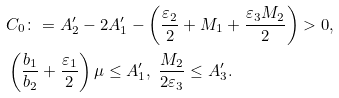<formula> <loc_0><loc_0><loc_500><loc_500>& C _ { 0 } \colon = A ^ { \prime } _ { 2 } - 2 A ^ { \prime } _ { 1 } - \left ( \frac { \varepsilon _ { 2 } } { 2 } + M _ { 1 } + \frac { \varepsilon _ { 3 } M _ { 2 } } { 2 } \right ) > 0 , \\ & \left ( \frac { b _ { 1 } } { b _ { 2 } } + \frac { \varepsilon _ { 1 } } { 2 } \right ) \mu \leq A ^ { \prime } _ { 1 } , \ \frac { M _ { 2 } } { 2 \varepsilon _ { 3 } } \leq A ^ { \prime } _ { 3 } .</formula> 